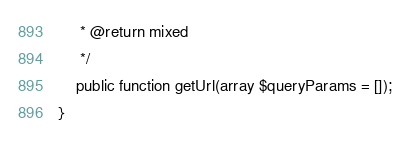<code> <loc_0><loc_0><loc_500><loc_500><_PHP_>     * @return mixed
     */
    public function getUrl(array $queryParams = []);
}
</code> 